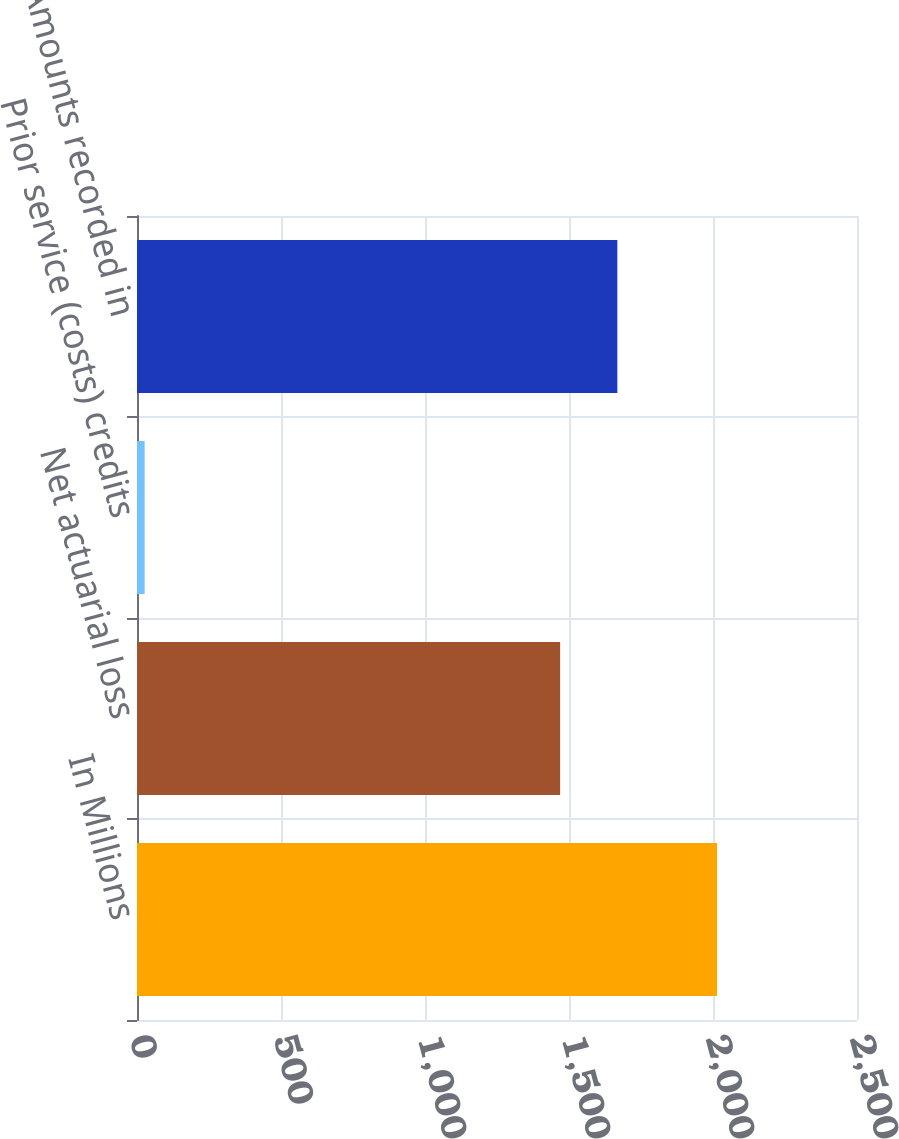Convert chart. <chart><loc_0><loc_0><loc_500><loc_500><bar_chart><fcel>In Millions<fcel>Net actuarial loss<fcel>Prior service (costs) credits<fcel>Amounts recorded in<nl><fcel>2014<fcel>1469.2<fcel>26.5<fcel>1667.95<nl></chart> 